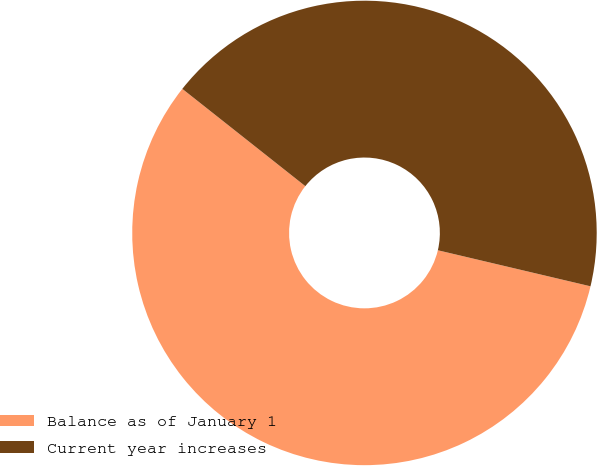<chart> <loc_0><loc_0><loc_500><loc_500><pie_chart><fcel>Balance as of January 1<fcel>Current year increases<nl><fcel>56.96%<fcel>43.04%<nl></chart> 